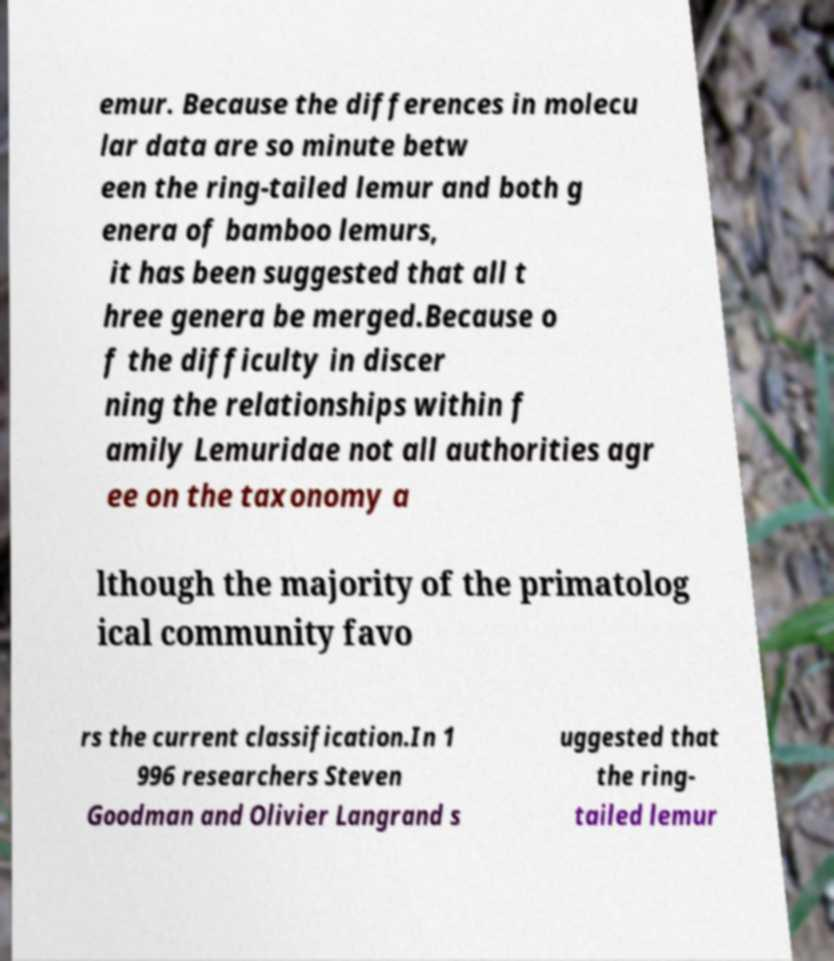Please read and relay the text visible in this image. What does it say? emur. Because the differences in molecu lar data are so minute betw een the ring-tailed lemur and both g enera of bamboo lemurs, it has been suggested that all t hree genera be merged.Because o f the difficulty in discer ning the relationships within f amily Lemuridae not all authorities agr ee on the taxonomy a lthough the majority of the primatolog ical community favo rs the current classification.In 1 996 researchers Steven Goodman and Olivier Langrand s uggested that the ring- tailed lemur 